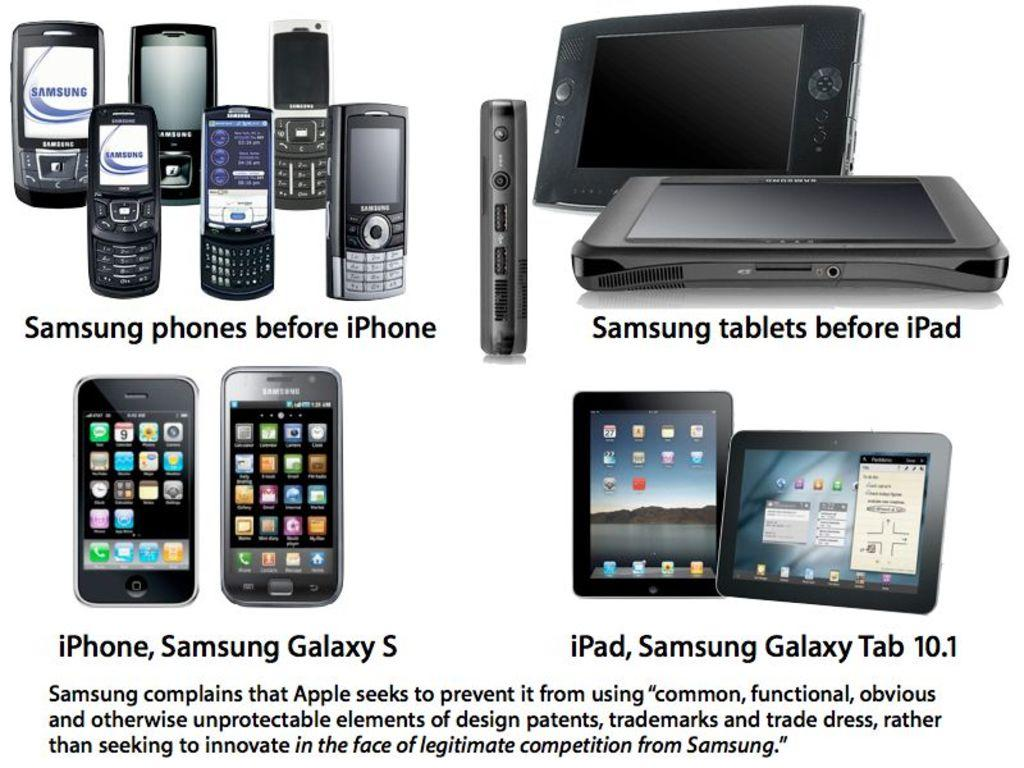<image>
Offer a succinct explanation of the picture presented. A collection of electronic devices including samsung and iPhones. 